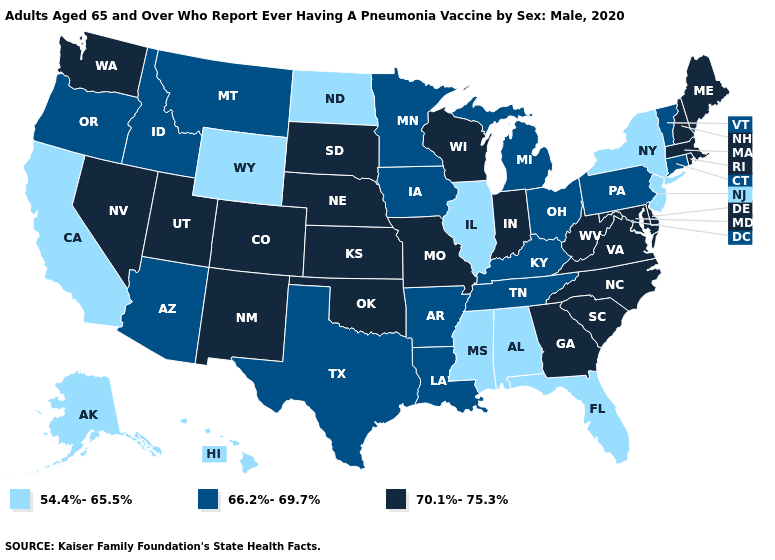What is the highest value in the Northeast ?
Concise answer only. 70.1%-75.3%. What is the lowest value in the West?
Give a very brief answer. 54.4%-65.5%. Name the states that have a value in the range 54.4%-65.5%?
Quick response, please. Alabama, Alaska, California, Florida, Hawaii, Illinois, Mississippi, New Jersey, New York, North Dakota, Wyoming. Name the states that have a value in the range 66.2%-69.7%?
Keep it brief. Arizona, Arkansas, Connecticut, Idaho, Iowa, Kentucky, Louisiana, Michigan, Minnesota, Montana, Ohio, Oregon, Pennsylvania, Tennessee, Texas, Vermont. Does Wisconsin have the highest value in the USA?
Write a very short answer. Yes. How many symbols are there in the legend?
Answer briefly. 3. Does Massachusetts have a lower value than California?
Concise answer only. No. Does the first symbol in the legend represent the smallest category?
Be succinct. Yes. Name the states that have a value in the range 54.4%-65.5%?
Short answer required. Alabama, Alaska, California, Florida, Hawaii, Illinois, Mississippi, New Jersey, New York, North Dakota, Wyoming. What is the value of New York?
Write a very short answer. 54.4%-65.5%. What is the value of Kansas?
Keep it brief. 70.1%-75.3%. What is the value of Nevada?
Give a very brief answer. 70.1%-75.3%. Among the states that border North Dakota , which have the highest value?
Answer briefly. South Dakota. Does Iowa have a lower value than South Carolina?
Answer briefly. Yes. Name the states that have a value in the range 66.2%-69.7%?
Keep it brief. Arizona, Arkansas, Connecticut, Idaho, Iowa, Kentucky, Louisiana, Michigan, Minnesota, Montana, Ohio, Oregon, Pennsylvania, Tennessee, Texas, Vermont. 